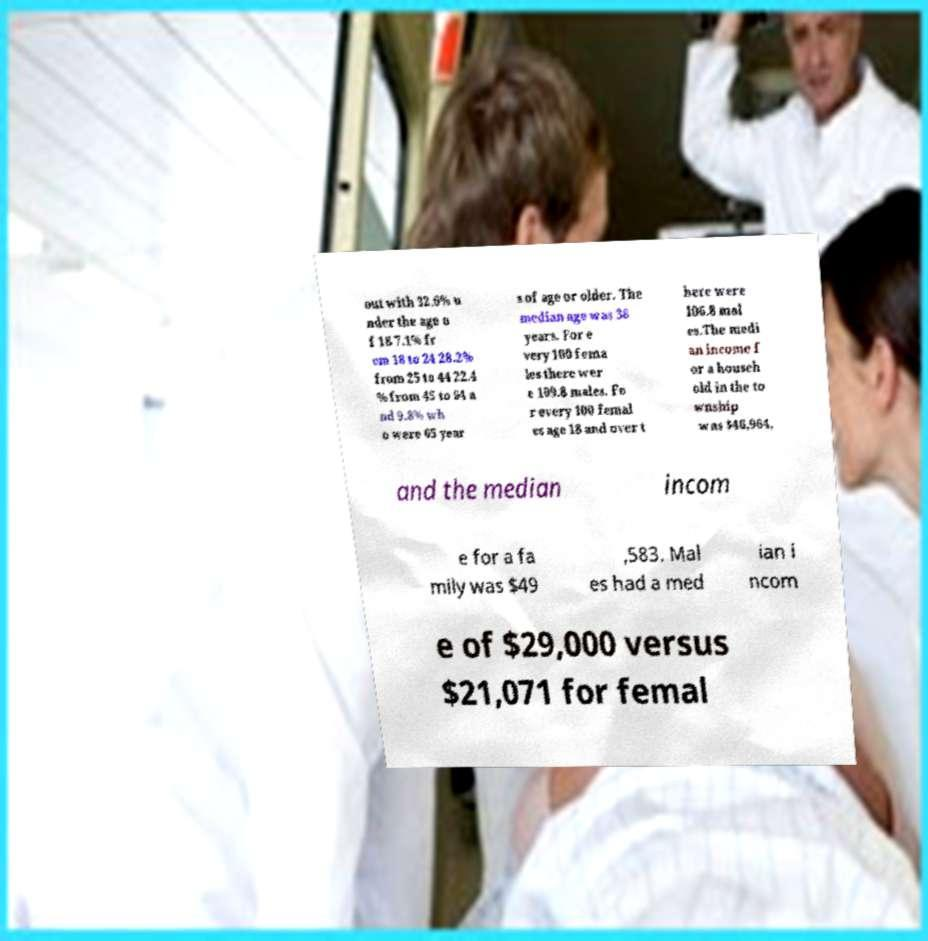What messages or text are displayed in this image? I need them in a readable, typed format. out with 32.6% u nder the age o f 18 7.1% fr om 18 to 24 28.2% from 25 to 44 22.4 % from 45 to 64 a nd 9.8% wh o were 65 year s of age or older. The median age was 36 years. For e very 100 fema les there wer e 109.8 males. Fo r every 100 femal es age 18 and over t here were 106.8 mal es.The medi an income f or a househ old in the to wnship was $46,964, and the median incom e for a fa mily was $49 ,583. Mal es had a med ian i ncom e of $29,000 versus $21,071 for femal 